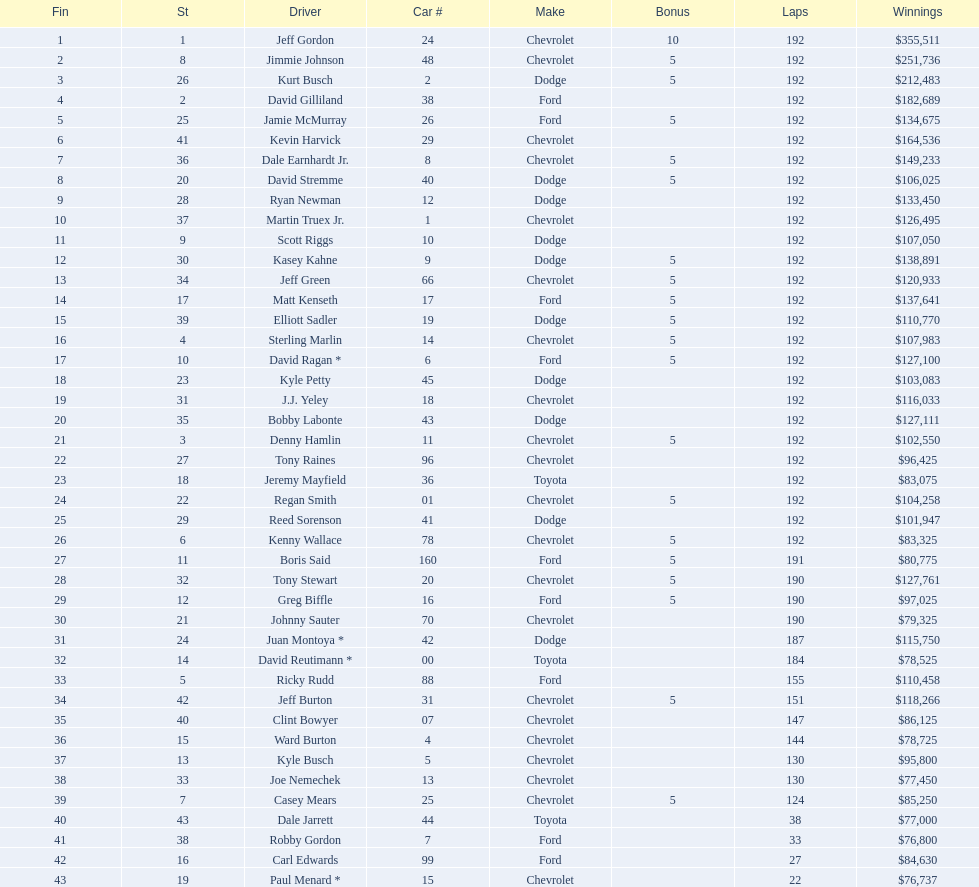What driver earned the least amount of winnings? Paul Menard *. 